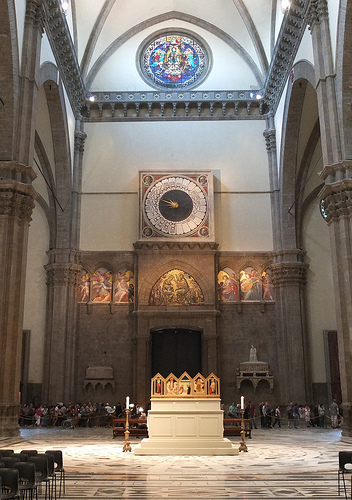Is there a rectangular door or window? No, there is neither a rectangular door nor a window visible. 